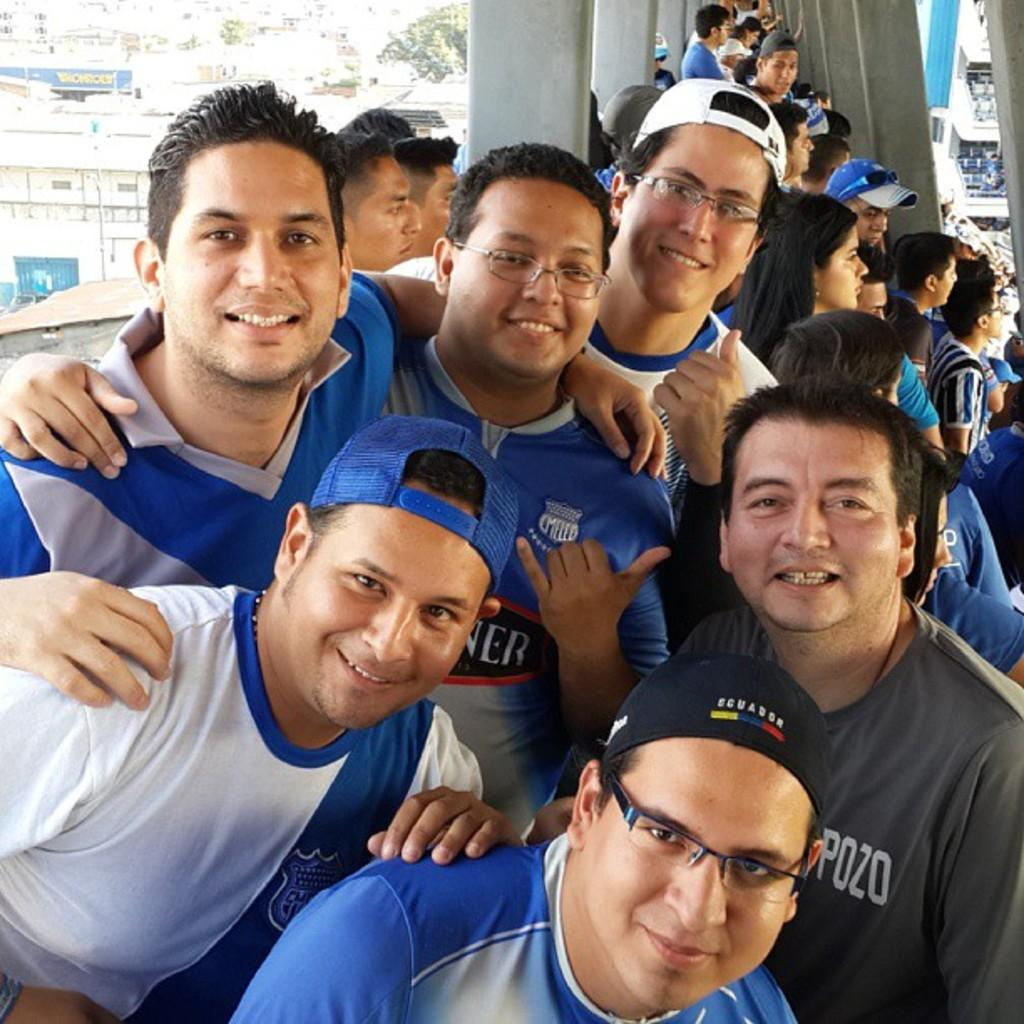How many people are visible in the image? There are many people in the image. What type of structures can be seen in the image? There are many buildings in the image. What architectural feature is present in the image? There are pillars in the image. What type of insurance policy do the people in the image have? There is no information about insurance policies in the image. 